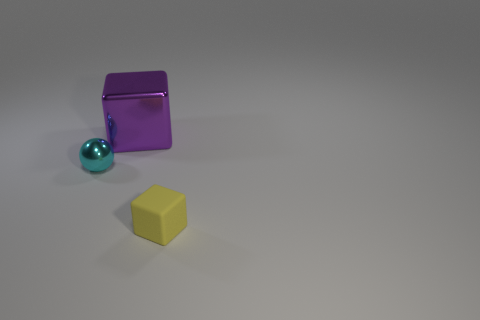Add 1 spheres. How many objects exist? 4 Subtract all spheres. How many objects are left? 2 Subtract all yellow blocks. Subtract all yellow balls. How many blocks are left? 1 Subtract all purple blocks. Subtract all small metallic things. How many objects are left? 1 Add 2 yellow blocks. How many yellow blocks are left? 3 Add 3 big brown matte spheres. How many big brown matte spheres exist? 3 Subtract 0 gray balls. How many objects are left? 3 